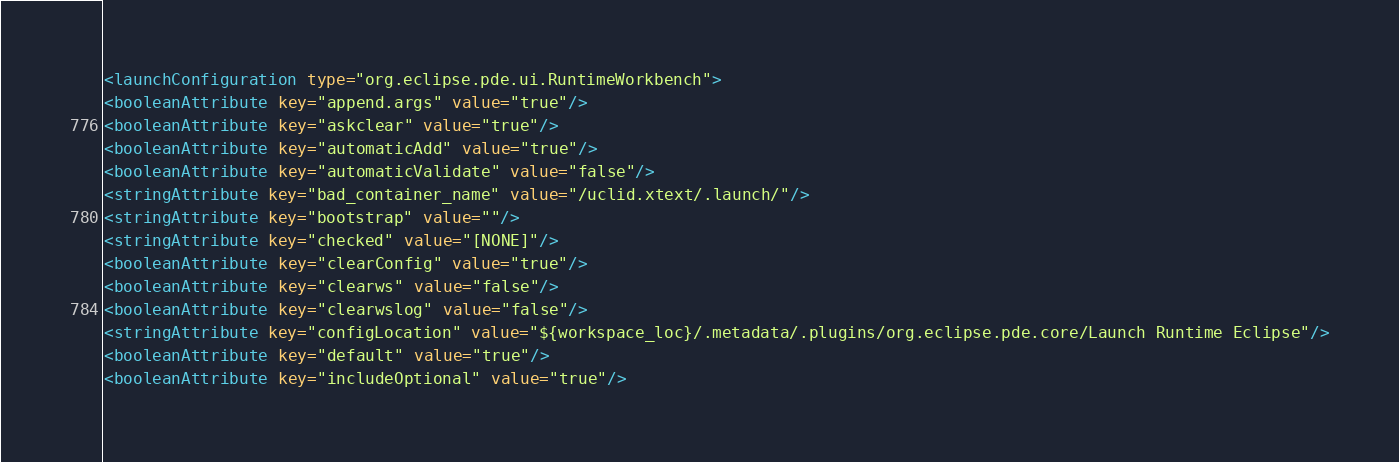Convert code to text. <code><loc_0><loc_0><loc_500><loc_500><_XML_><launchConfiguration type="org.eclipse.pde.ui.RuntimeWorkbench">
<booleanAttribute key="append.args" value="true"/>
<booleanAttribute key="askclear" value="true"/>
<booleanAttribute key="automaticAdd" value="true"/>
<booleanAttribute key="automaticValidate" value="false"/>
<stringAttribute key="bad_container_name" value="/uclid.xtext/.launch/"/>
<stringAttribute key="bootstrap" value=""/>
<stringAttribute key="checked" value="[NONE]"/>
<booleanAttribute key="clearConfig" value="true"/>
<booleanAttribute key="clearws" value="false"/>
<booleanAttribute key="clearwslog" value="false"/>
<stringAttribute key="configLocation" value="${workspace_loc}/.metadata/.plugins/org.eclipse.pde.core/Launch Runtime Eclipse"/>
<booleanAttribute key="default" value="true"/>
<booleanAttribute key="includeOptional" value="true"/></code> 